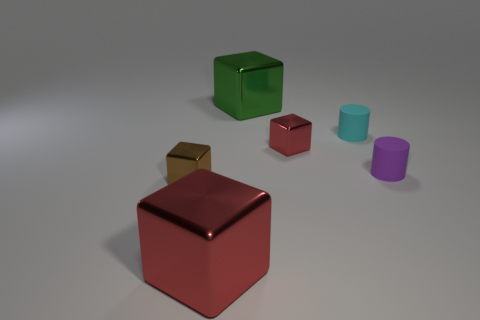Subtract all small brown cubes. How many cubes are left? 3 Add 3 tiny red cubes. How many objects exist? 9 Subtract 3 cubes. How many cubes are left? 1 Subtract all green cubes. How many cubes are left? 3 Subtract 1 brown cubes. How many objects are left? 5 Subtract all cylinders. How many objects are left? 4 Subtract all gray cubes. Subtract all brown cylinders. How many cubes are left? 4 Subtract all cyan cylinders. How many purple blocks are left? 0 Subtract all green shiny cylinders. Subtract all cyan rubber things. How many objects are left? 5 Add 6 tiny objects. How many tiny objects are left? 10 